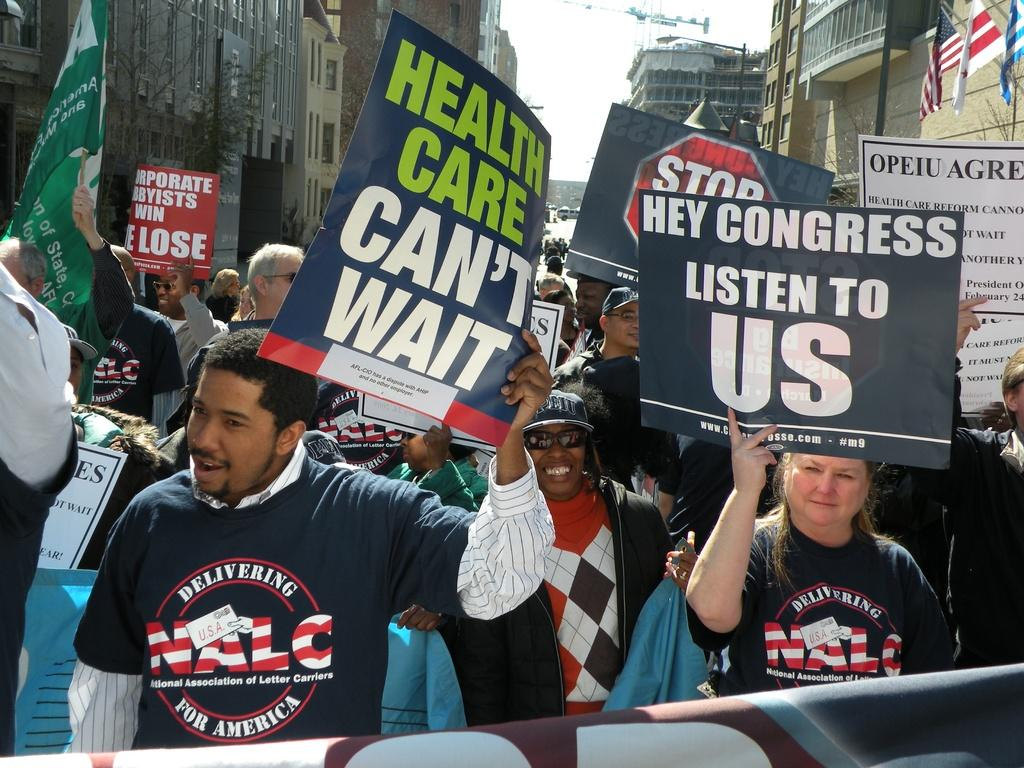Who or what is present in the image? There are people in the image. What are the people holding in the image? The people are holding placards. What can be seen in the background of the image? There are buildings and the sky visible in the background of the image. What type of wren can be seen perched on the basket in the image? There is no wren or basket present in the image. 